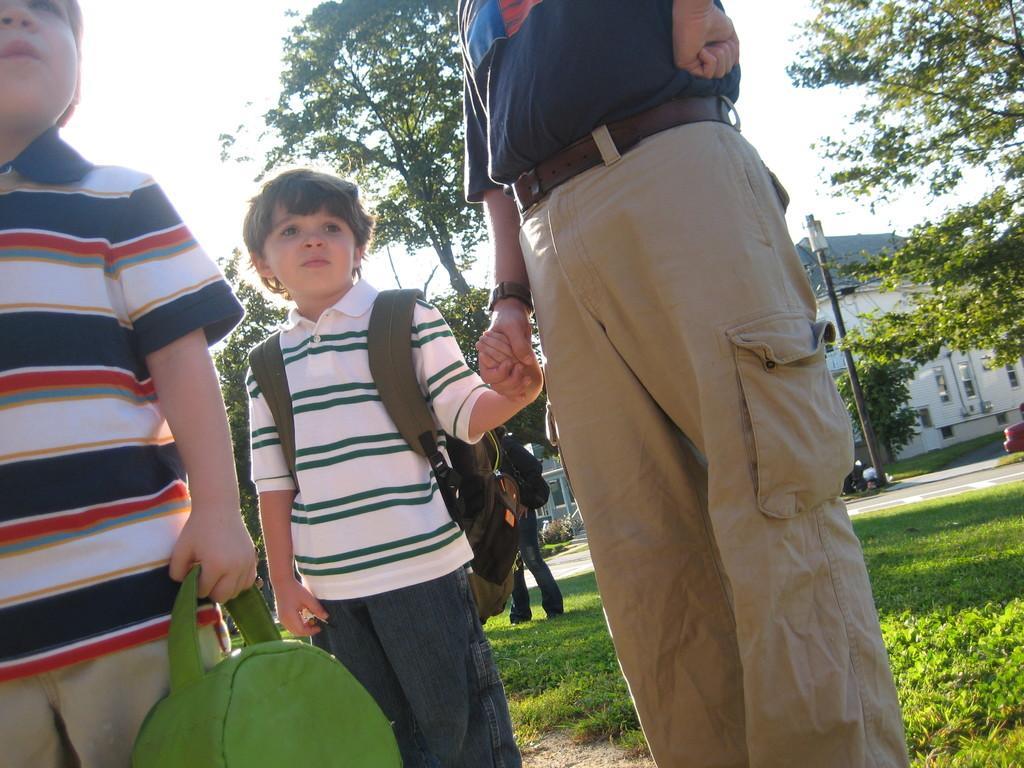Can you describe this image briefly? This picture describes about group of people, in the left side of the image we can see a boy, he is holding a bag, beside to him we can see another boy and he wore a backpack, in the background we can see a pole, trees and buildings. 